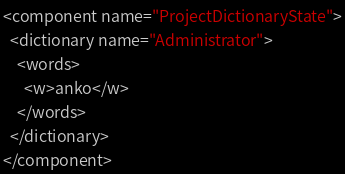Convert code to text. <code><loc_0><loc_0><loc_500><loc_500><_XML_><component name="ProjectDictionaryState">
  <dictionary name="Administrator">
    <words>
      <w>anko</w>
    </words>
  </dictionary>
</component></code> 